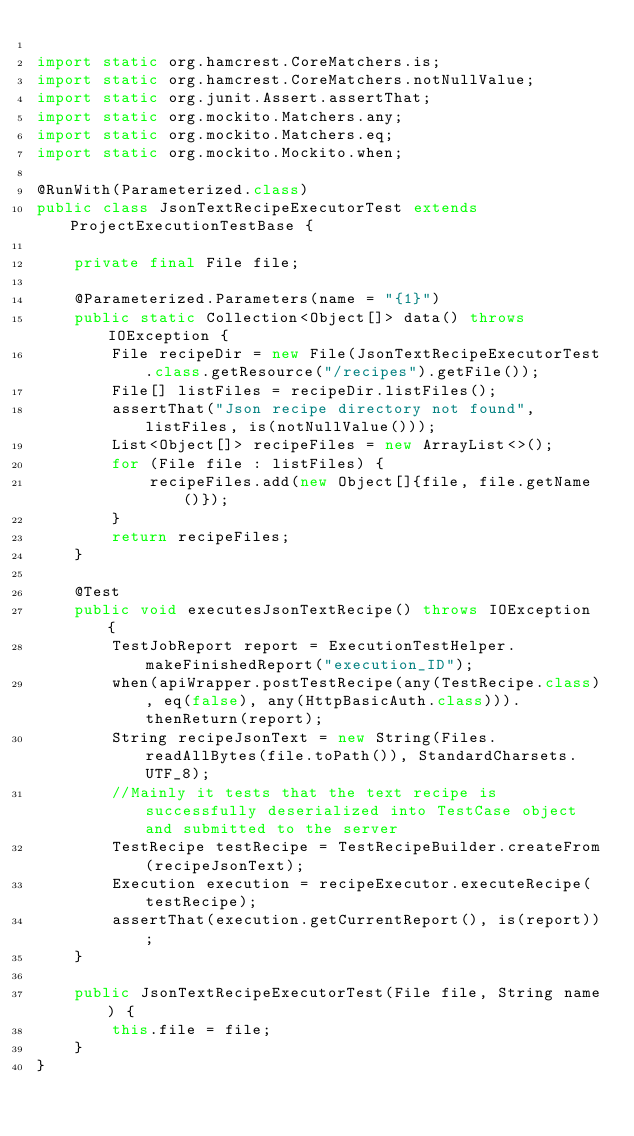<code> <loc_0><loc_0><loc_500><loc_500><_Java_>
import static org.hamcrest.CoreMatchers.is;
import static org.hamcrest.CoreMatchers.notNullValue;
import static org.junit.Assert.assertThat;
import static org.mockito.Matchers.any;
import static org.mockito.Matchers.eq;
import static org.mockito.Mockito.when;

@RunWith(Parameterized.class)
public class JsonTextRecipeExecutorTest extends ProjectExecutionTestBase {

    private final File file;

    @Parameterized.Parameters(name = "{1}")
    public static Collection<Object[]> data() throws IOException {
        File recipeDir = new File(JsonTextRecipeExecutorTest.class.getResource("/recipes").getFile());
        File[] listFiles = recipeDir.listFiles();
        assertThat("Json recipe directory not found", listFiles, is(notNullValue()));
        List<Object[]> recipeFiles = new ArrayList<>();
        for (File file : listFiles) {
            recipeFiles.add(new Object[]{file, file.getName()});
        }
        return recipeFiles;
    }

    @Test
    public void executesJsonTextRecipe() throws IOException {
        TestJobReport report = ExecutionTestHelper.makeFinishedReport("execution_ID");
        when(apiWrapper.postTestRecipe(any(TestRecipe.class), eq(false), any(HttpBasicAuth.class))).thenReturn(report);
        String recipeJsonText = new String(Files.readAllBytes(file.toPath()), StandardCharsets.UTF_8);
        //Mainly it tests that the text recipe is successfully deserialized into TestCase object and submitted to the server
        TestRecipe testRecipe = TestRecipeBuilder.createFrom(recipeJsonText);
        Execution execution = recipeExecutor.executeRecipe(testRecipe);
        assertThat(execution.getCurrentReport(), is(report));
    }

    public JsonTextRecipeExecutorTest(File file, String name) {
        this.file = file;
    }
}
</code> 